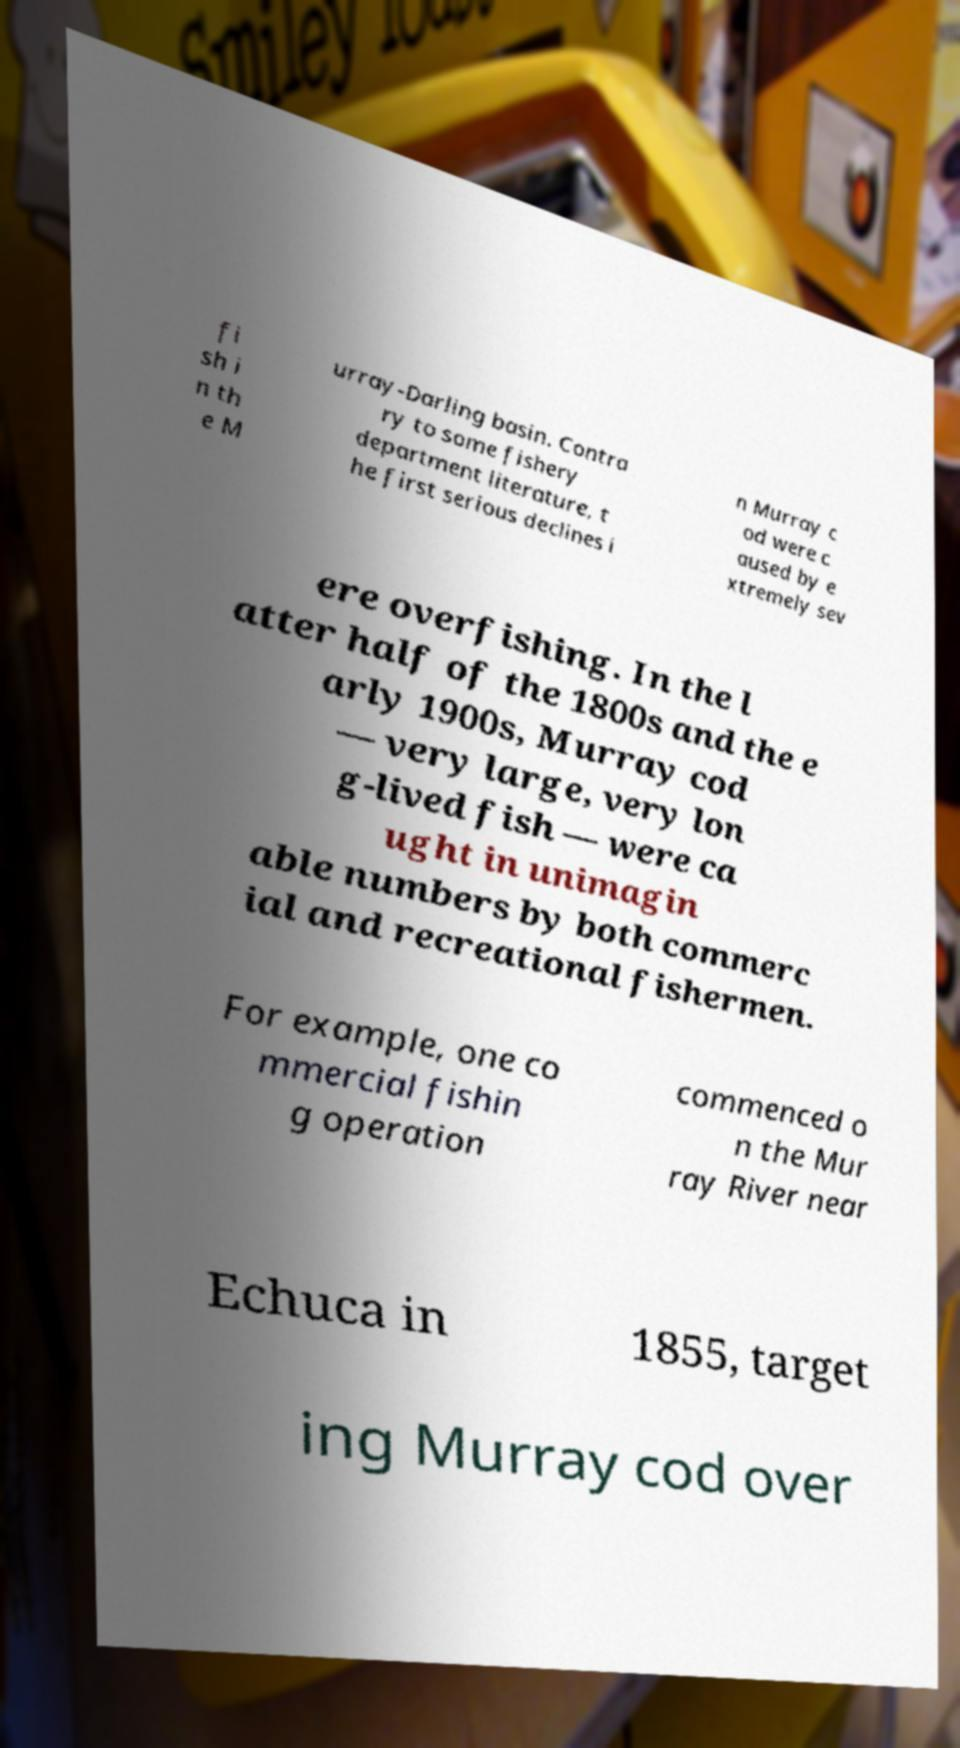Please identify and transcribe the text found in this image. fi sh i n th e M urray-Darling basin. Contra ry to some fishery department literature, t he first serious declines i n Murray c od were c aused by e xtremely sev ere overfishing. In the l atter half of the 1800s and the e arly 1900s, Murray cod — very large, very lon g-lived fish — were ca ught in unimagin able numbers by both commerc ial and recreational fishermen. For example, one co mmercial fishin g operation commenced o n the Mur ray River near Echuca in 1855, target ing Murray cod over 